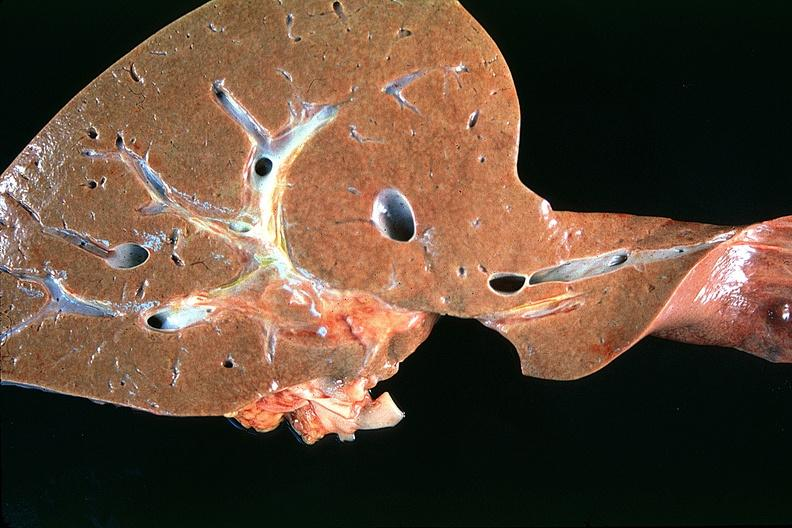s hepatobiliary present?
Answer the question using a single word or phrase. Yes 